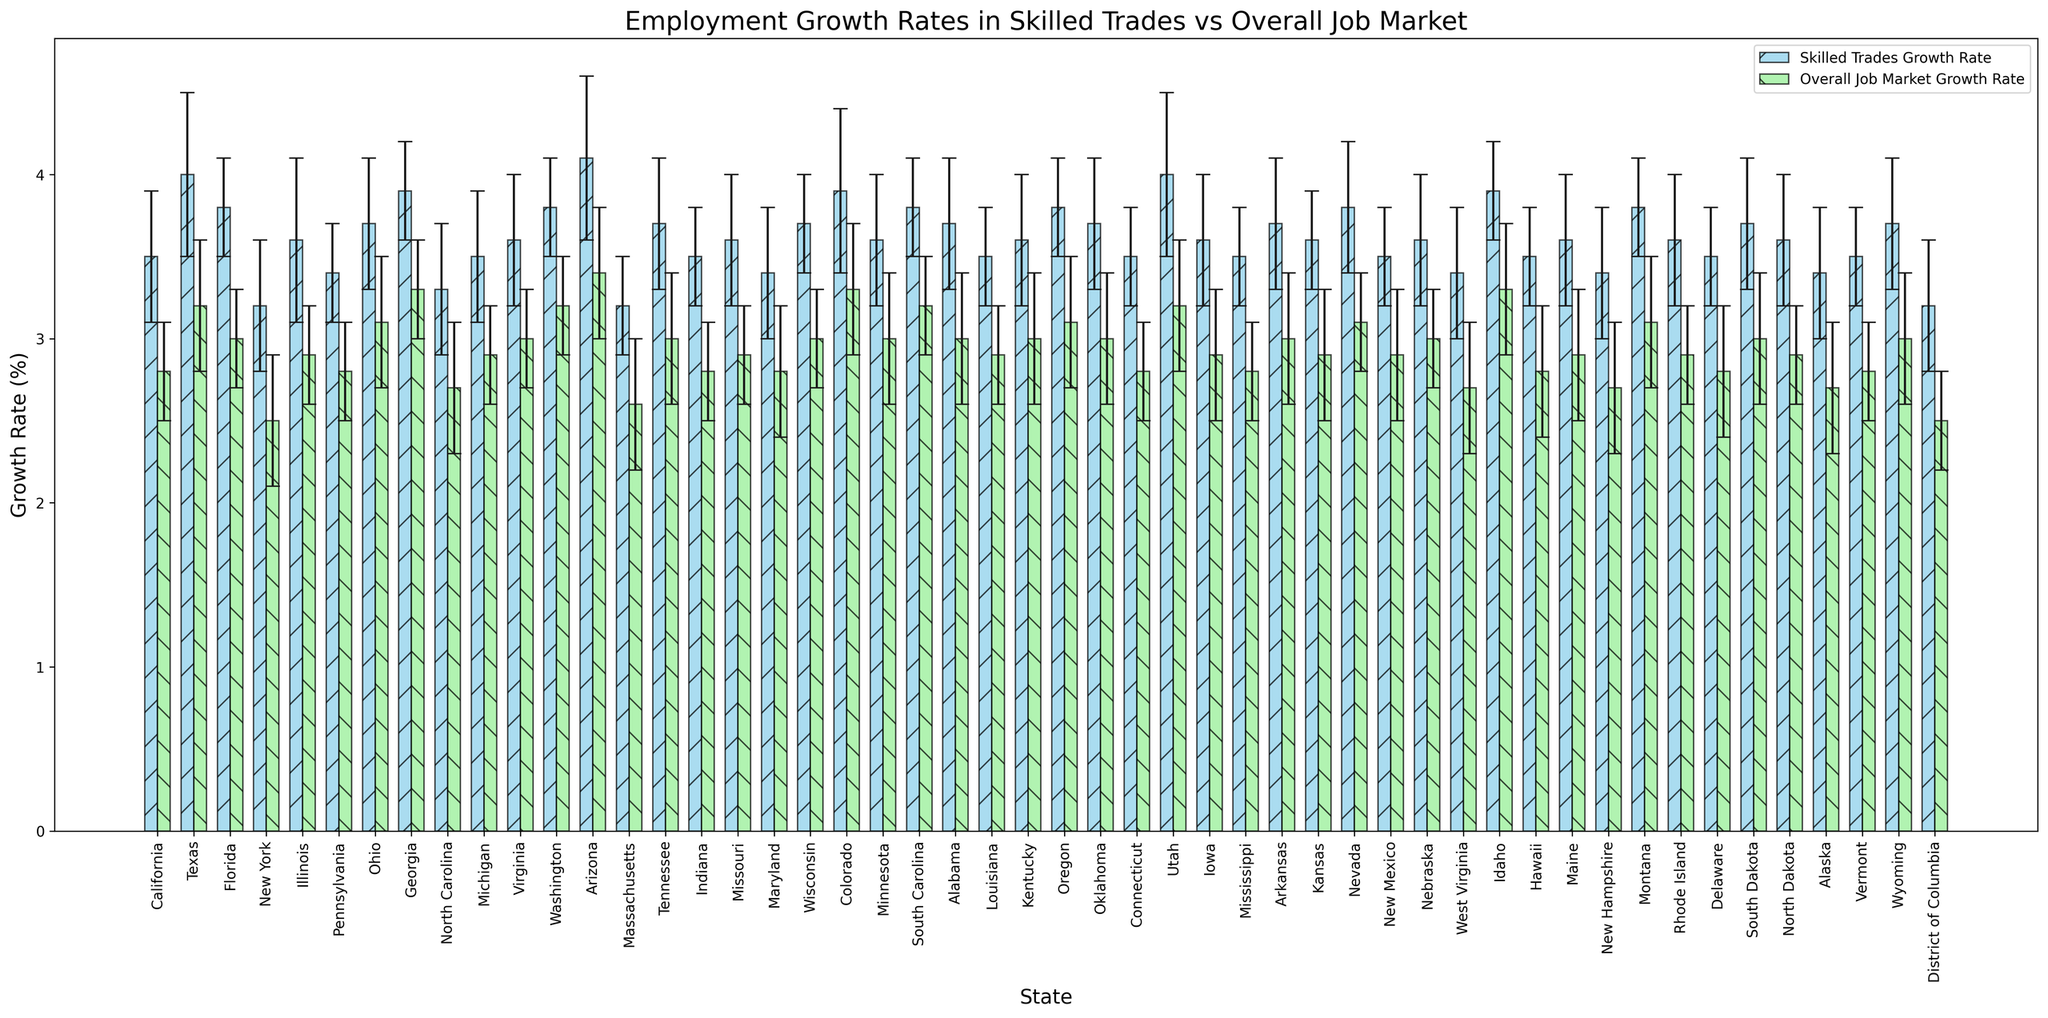Which state has the highest growth rate in skilled trades? Locate the tallest bar for skilled trades growth rate, which is color-coded in sky blue and pattern-marked with forward slashes (/). Arizona's bar is the tallest.
Answer: Arizona What is the difference in growth rate between skilled trades and the overall job market in Texas? Identify the bars for Texas. Skilled trades bar is 4.0% and overall job market bar is 3.2%. Subtract 3.2% from 4.0%.
Answer: 0.8% Which states have a higher overall job market growth rate than New York's skilled trades growth rate? New York's skilled trades growth rate bar is 3.2%. Identify bars in light green with growth rates higher than 3.2%. These states are Georgia, Idaho, Utah, Arizona, Colorado.
Answer: Georgia, Idaho, Utah, Arizona, Colorado What is the average skilled trades growth rate across all states? Total the growth rates for skilled trades and divide by the number of states (50). Sum = 178.8%. Average = 178.8/50 = 3.576%.
Answer: 3.576% Which states have the smallest standard deviation in skilled trades growth rate? Observe the error bars for skilled trades growth rates in sky blue color. States with smaller error bars are Delaware, Vermont, Florida, Idaho, Indiana, and Massachusetts.
Answer: Delaware, Vermont, Florida, Idaho, Indiana, Massachusetts In which state is the difference between skilled trades and overall job market growth rates the largest? Look at the differences between paired bars for each state. The largest difference is in Arizona (4.1 - 3.4 = 0.7%).
Answer: Arizona How does California's overall job market growth compare to the skilled trades growth rate in Virginia? Compare the light green bar for California's overall job market growth rate (2.8%) with the sky blue bar for Virginia's skilled trades growth rate (3.6%).
Answer: Virginia's skilled trades growth rate is higher What is the combined growth rate of skilled trades for the states of California, Texas, and Florida? Sum the growth rates for California (3.5%), Texas (4.0%), and Florida (3.8%). Total = 3.5 + 4.0 + 3.8 = 11.3%.
Answer: 11.3% Which state has almost equal growth rates for skilled trades and the overall job market? Identify states where bars are closely matched in height. For example, Ohio (3.7% for skilled trades and 3.1% for overall job market) is very close.
Answer: Ohio What is the range of growth rates in the skilled trades sector across all states? Find the highest (Arizona, 4.1%) and lowest (New York and Massachusetts, 3.2%) bars for skilled trades. Subtract the lowest from the highest. 4.1 - 3.2 = 0.9%.
Answer: 0.9% 